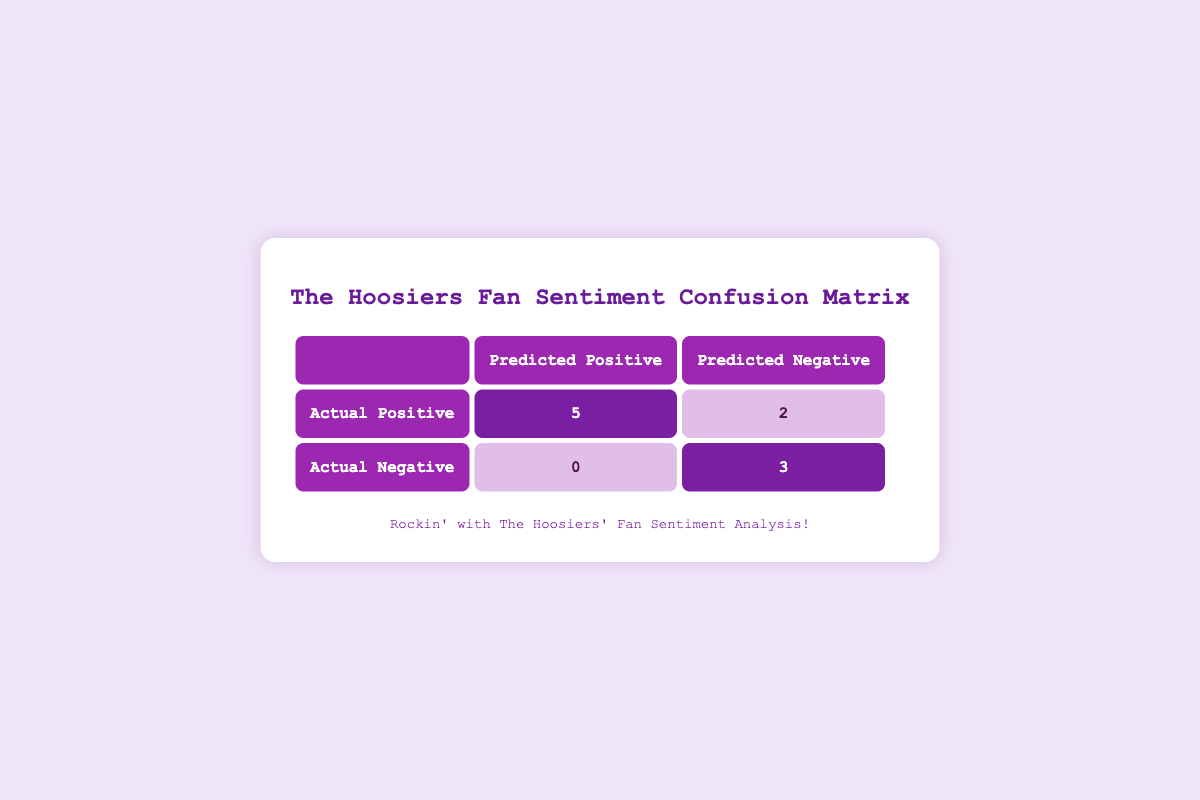What is the number of actual positive cases? The number of actual positive cases can be found by looking at the "Actual Positive" row. The total for that row is 6 (True Positive) + 2 (False Negative) = 8, but since we're only looking for actual positive cases, we focus on the value of 6 in the True Positive cell.
Answer: 6 What is the number of false negatives? False negatives can be found by examining the "Actual Positive" row and the "Predicted Negative" column. The value in that cell is 2, representing cases where the actual sentiment was positive, but it was incorrectly predicted as negative.
Answer: 2 How many total comments have a positive predicted sentiment? To find the total for positive predicted sentiment, add the values in the cells under the "Predicted Positive" column: 6 (True Positive) from actual positive and 0 (False Positive) from actual negative. This results in 6 + 0 = 6 comments predicted as positive.
Answer: 6 Is the number of true positives greater than the number of true negatives? The number of true positives is 6 while the number of true negatives is 2. Since 6 is greater than 2, the answer is true. This shows effective sentiment predictions for positive comments compared to negative ones.
Answer: Yes What is the ratio of true positives to false positives? The ratio of true positives (6) to false positives (0) can be calculated as 6:0. Since there are no false positives, we can't compute a traditional ratio, but conceptually, it's infinite, indicating that every positive case was predicted correctly without errors.
Answer: Undefined (or infinite) 